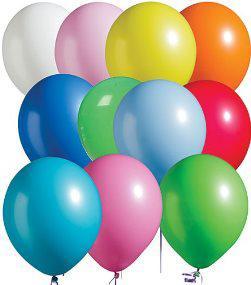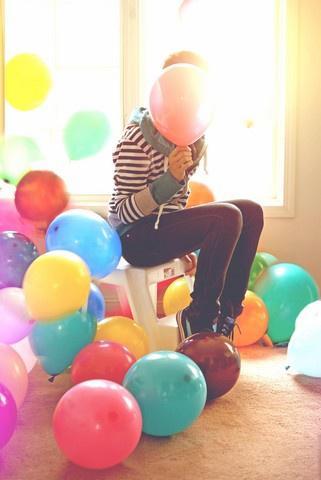The first image is the image on the left, the second image is the image on the right. Examine the images to the left and right. Is the description "One of the images shows someone holding at least one balloon and the other image shows a bunch of balloons in different colors." accurate? Answer yes or no. Yes. The first image is the image on the left, the second image is the image on the right. Assess this claim about the two images: "In one image there is a person holding at least 1 balloon.". Correct or not? Answer yes or no. Yes. 